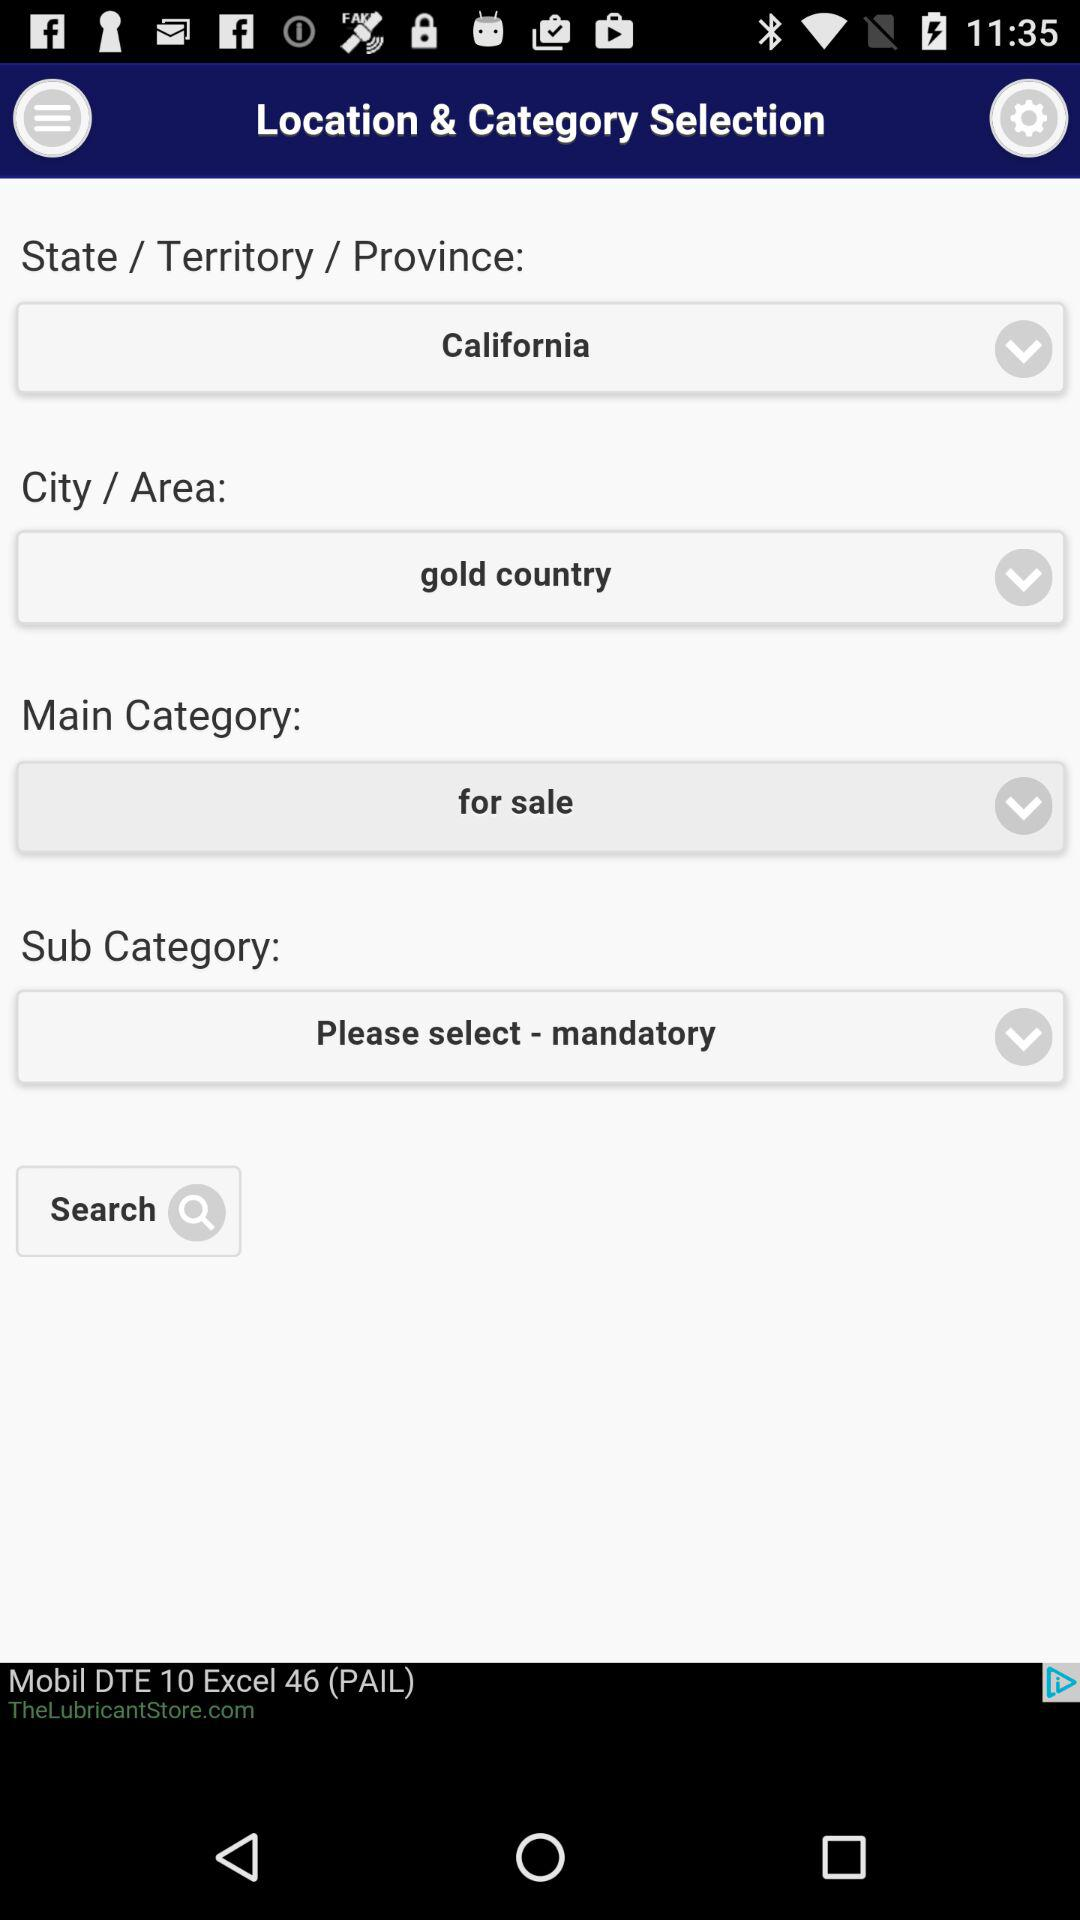What sub category is selected? The selected sub category is "mandatory". 